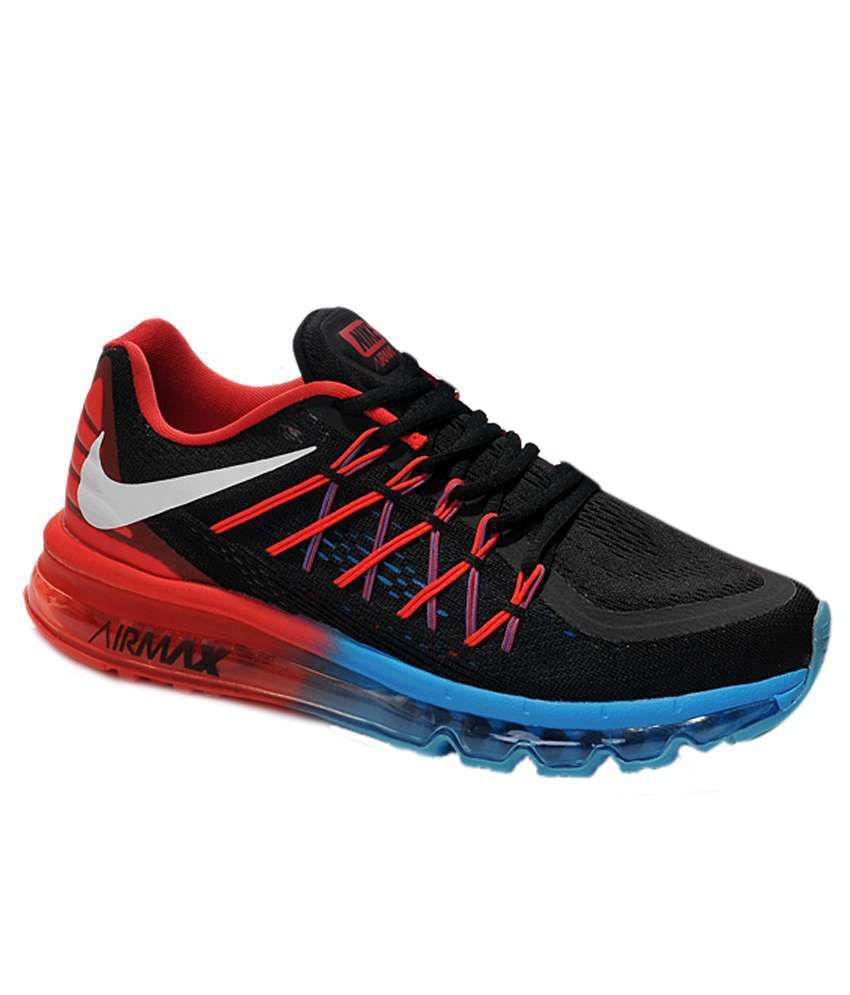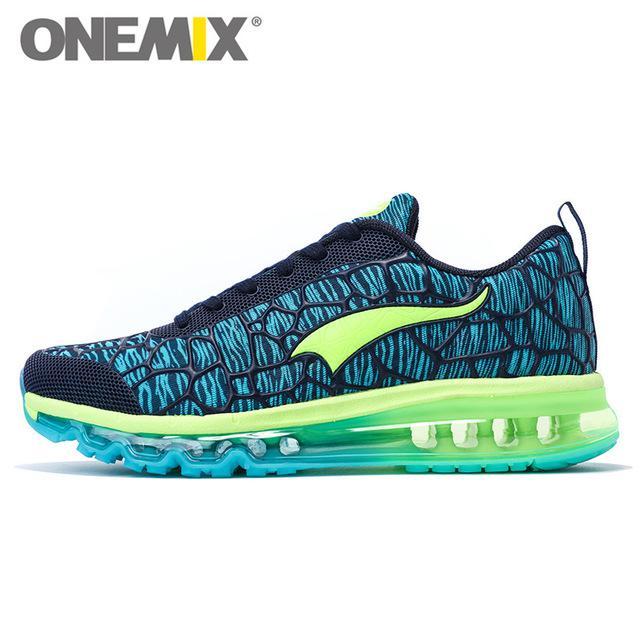The first image is the image on the left, the second image is the image on the right. Examine the images to the left and right. Is the description "One image shows at least one black-laced shoe that is black with red and blue trim." accurate? Answer yes or no. Yes. The first image is the image on the left, the second image is the image on the right. Analyze the images presented: Is the assertion "A shoe facing left has a lime green ribbon shape on it in one image." valid? Answer yes or no. Yes. 